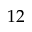<formula> <loc_0><loc_0><loc_500><loc_500>1 2</formula> 